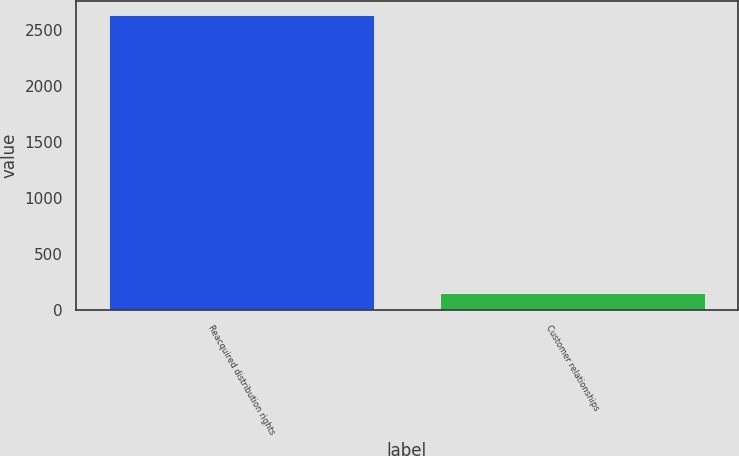Convert chart to OTSL. <chart><loc_0><loc_0><loc_500><loc_500><bar_chart><fcel>Reacquired distribution rights<fcel>Customer relationships<nl><fcel>2628<fcel>148<nl></chart> 